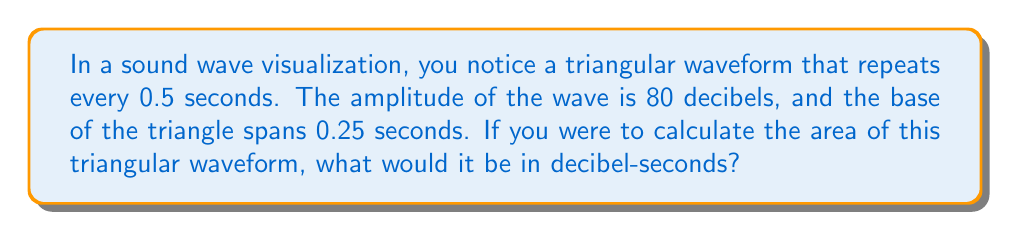Solve this math problem. Let's approach this step-by-step:

1) First, we need to identify the shape we're dealing with. In this case, it's a triangle.

2) The formula for the area of a triangle is:

   $$A = \frac{1}{2} \times base \times height$$

3) We're given the following information:
   - Base of the triangle = 0.25 seconds
   - Height of the triangle (amplitude) = 80 decibels

4) Let's plug these values into our formula:

   $$A = \frac{1}{2} \times 0.25 \text{ seconds} \times 80 \text{ decibels}$$

5) Now, let's calculate:

   $$A = \frac{1}{2} \times 20 \text{ decibel-seconds}$$
   $$A = 10 \text{ decibel-seconds}$$

6) Therefore, the area of the triangular waveform is 10 decibel-seconds.

[asy]
size(200,100);
draw((0,0)--(50,80)--(100,0));
label("0.25 s", (50,-10));
label("80 dB", (55,40), E);
[/asy]

This visualization represents the triangular waveform described in the problem.
Answer: 10 decibel-seconds 